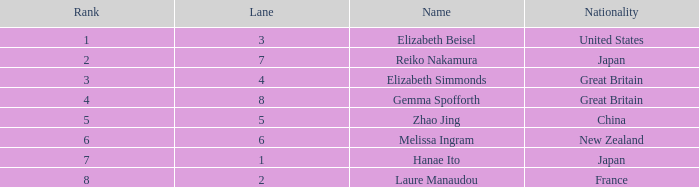What is Elizabeth Simmonds' average lane number? 4.0. 